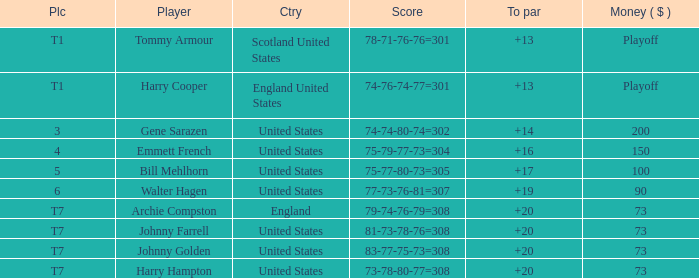What is the ranking for the United States when the money is $200? 3.0. 